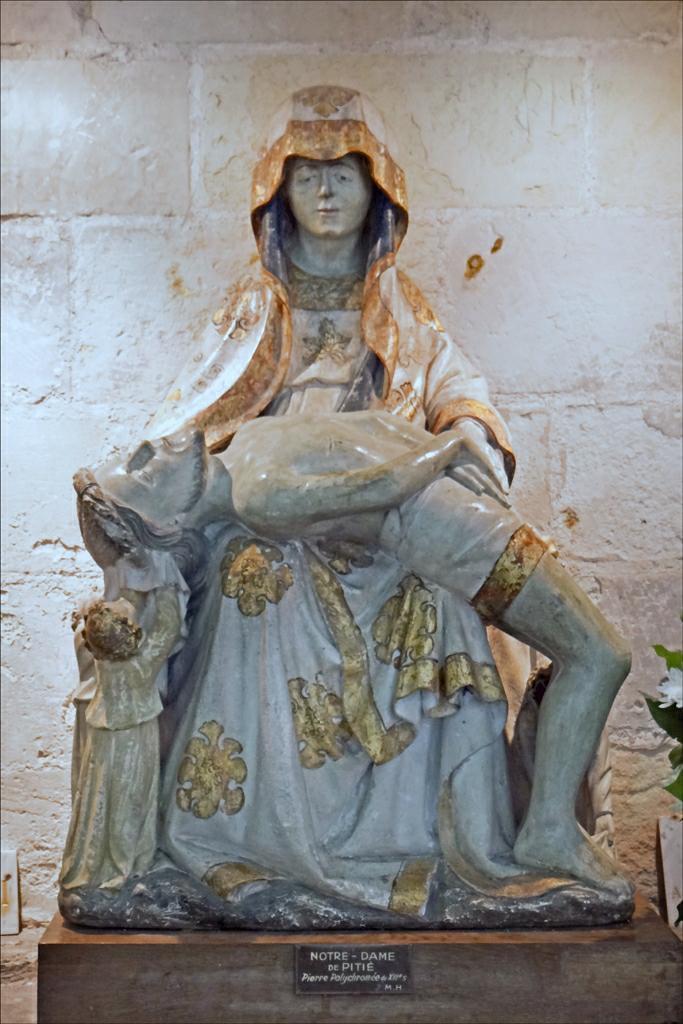Can you describe this image briefly? Here we can see a sculpture. Background it is in white color. 